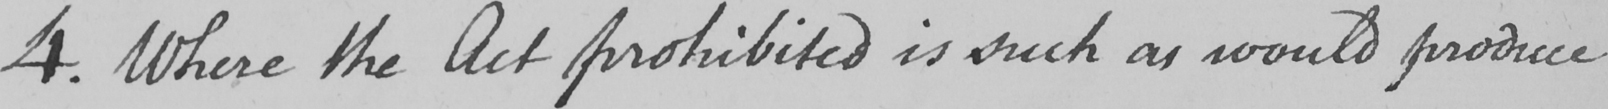What does this handwritten line say? 4 . Where the Act prohibited is such as would produce 